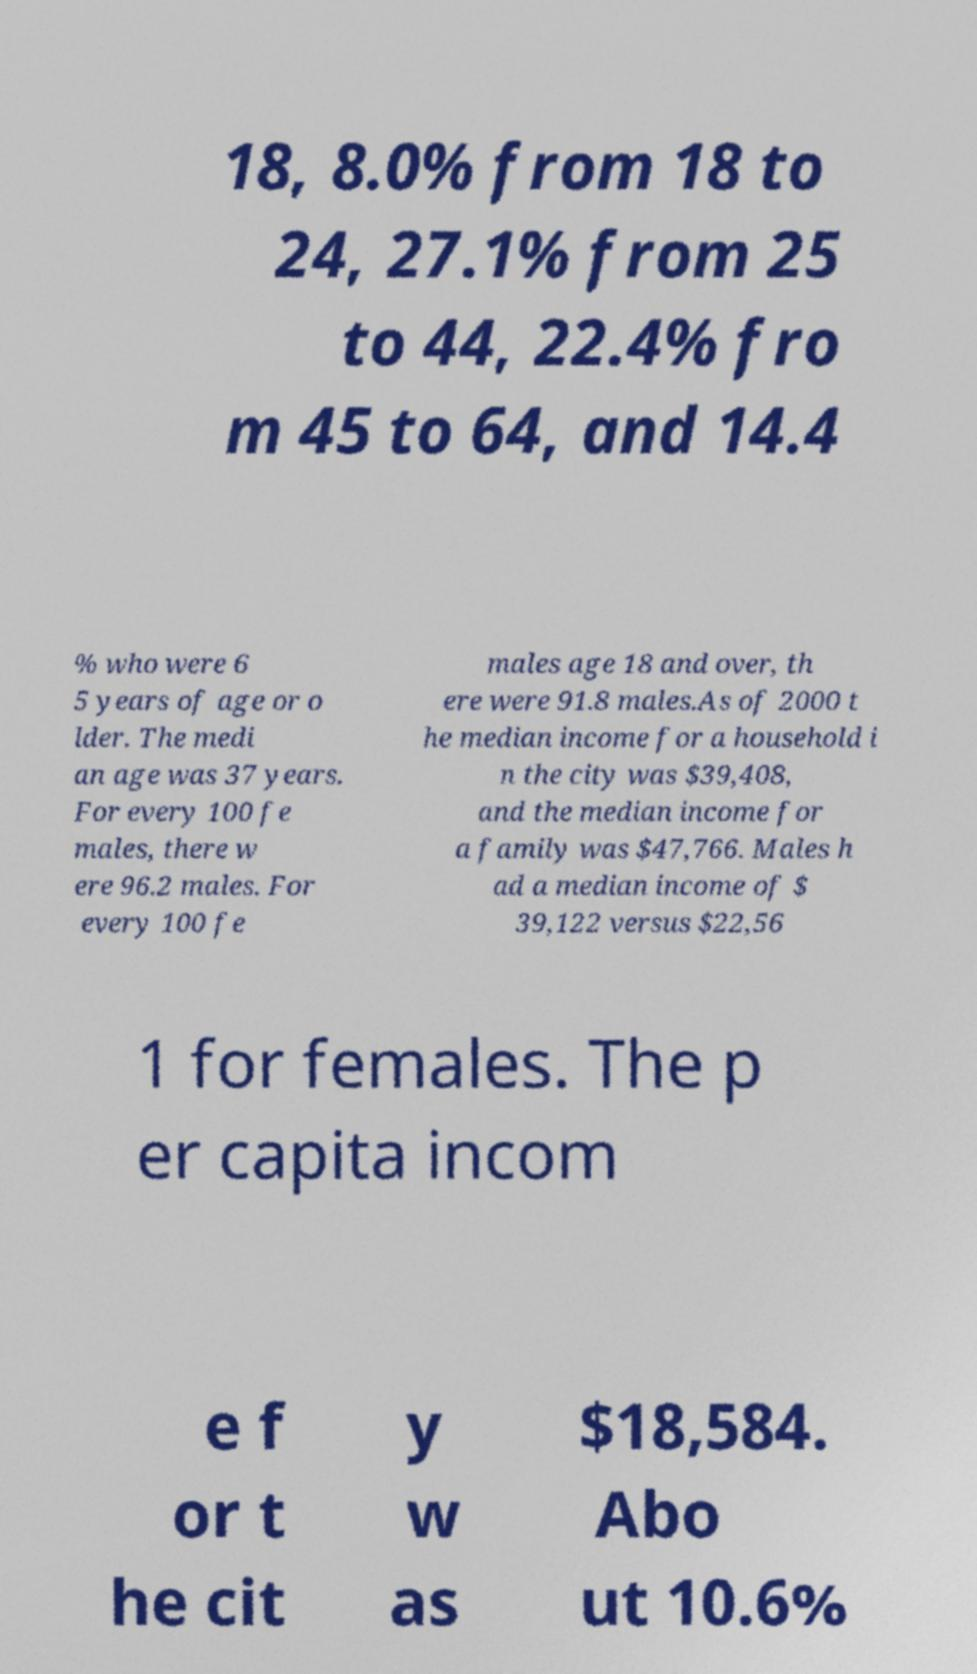Please read and relay the text visible in this image. What does it say? 18, 8.0% from 18 to 24, 27.1% from 25 to 44, 22.4% fro m 45 to 64, and 14.4 % who were 6 5 years of age or o lder. The medi an age was 37 years. For every 100 fe males, there w ere 96.2 males. For every 100 fe males age 18 and over, th ere were 91.8 males.As of 2000 t he median income for a household i n the city was $39,408, and the median income for a family was $47,766. Males h ad a median income of $ 39,122 versus $22,56 1 for females. The p er capita incom e f or t he cit y w as $18,584. Abo ut 10.6% 